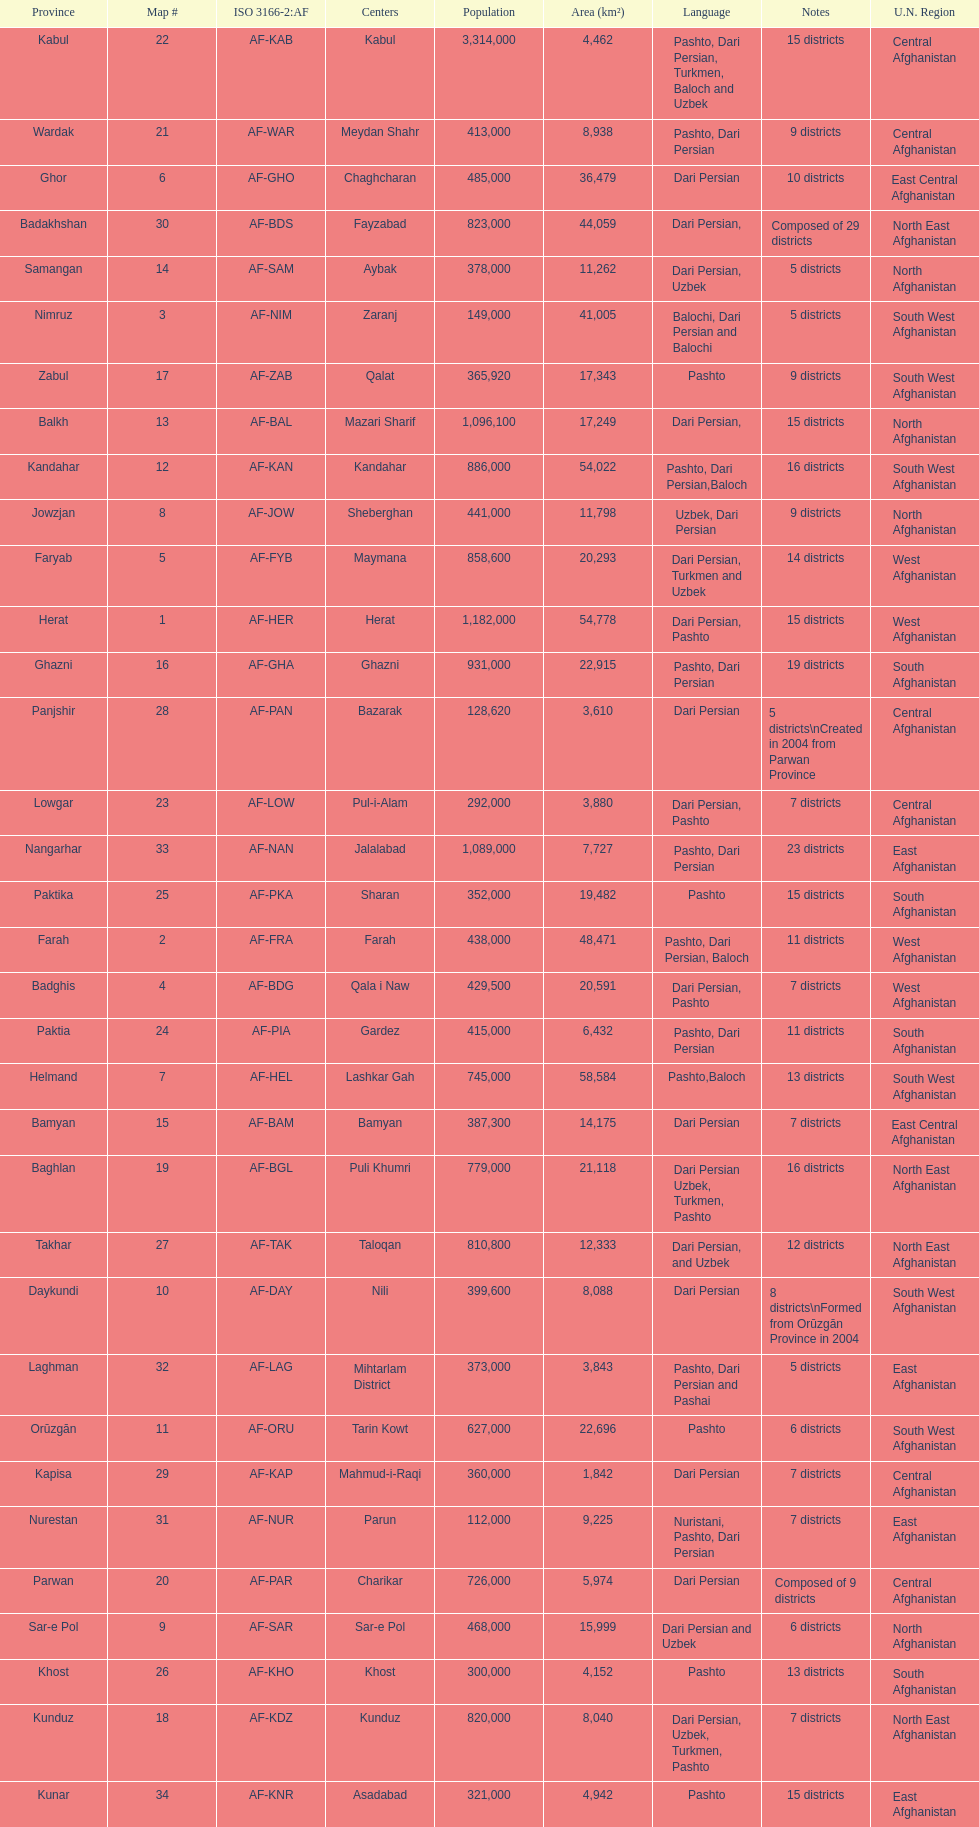How many provinces have the same number of districts as kabul? 4. 